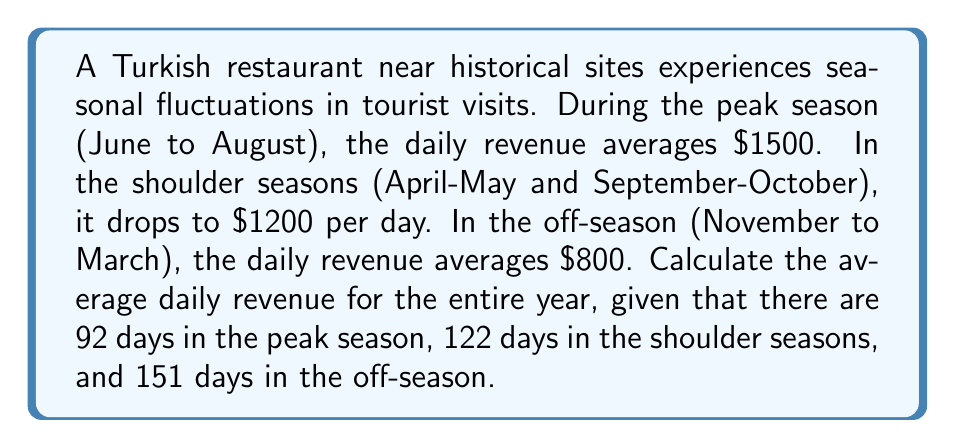Help me with this question. To calculate the average daily revenue for the entire year, we need to:

1. Calculate the total revenue for each season
2. Sum up the total revenue for the year
3. Divide the total yearly revenue by the number of days in a year

Let's break it down step-by-step:

1. Calculate the total revenue for each season:
   Peak season: $1500 \times 92 = $138,000
   Shoulder seasons: $1200 \times 122 = $146,400
   Off-season: $800 \times 151 = $120,800

2. Sum up the total revenue for the year:
   $$\text{Total yearly revenue} = $138,000 + $146,400 + $120,800 = $405,200$$

3. Calculate the average daily revenue:
   $$\text{Average daily revenue} = \frac{\text{Total yearly revenue}}{\text{Number of days in a year}}$$
   $$= \frac{$405,200}{365} \approx $1,110.14$$

Therefore, the average daily revenue for the entire year is approximately $1,110.14.
Answer: $1,110.14 